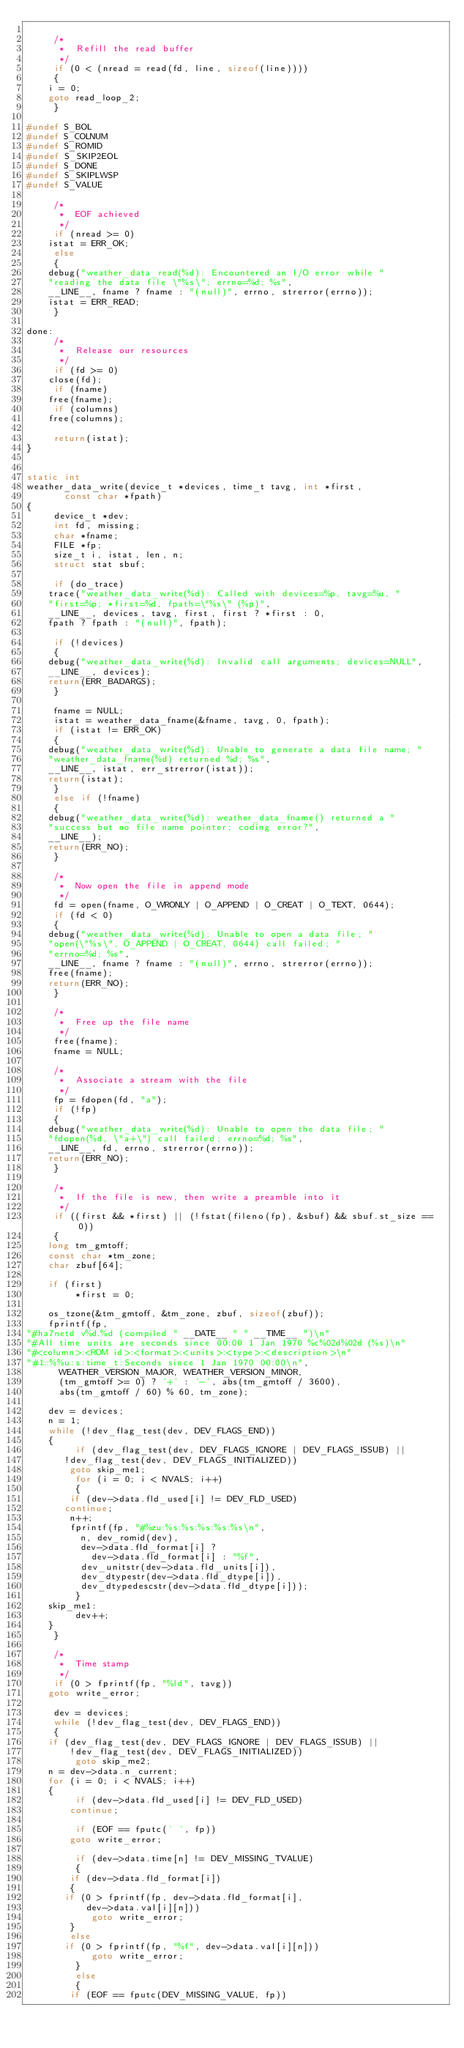<code> <loc_0><loc_0><loc_500><loc_500><_C_>
     /*
      *  Refill the read buffer
      */
     if (0 < (nread = read(fd, line, sizeof(line))))
     {
	  i = 0;
	  goto read_loop_2;
     }

#undef S_BOL
#undef S_COLNUM
#undef S_ROMID
#undef S_SKIP2EOL
#undef S_DONE
#undef S_SKIPLWSP
#undef S_VALUE

     /*
      *  EOF achieved
      */
     if (nread >= 0)
	  istat = ERR_OK;
     else
     {
	  debug("weather_data_read(%d): Encountered an I/O error while "
		"reading the data file \"%s\"; errno=%d; %s",
		__LINE__, fname ? fname : "(null)", errno, strerror(errno));
	  istat = ERR_READ;
     }

done:
     /*
      *  Release our resources
      */
     if (fd >= 0)
	  close(fd);
     if (fname)
	  free(fname);
     if (columns)
	  free(columns);

     return(istat);
}


static int
weather_data_write(device_t *devices, time_t tavg, int *first,
		   const char *fpath)
{
     device_t *dev;
     int fd, missing;
     char *fname;
     FILE *fp;
     size_t i, istat, len, n;
     struct stat sbuf;

     if (do_trace)
	  trace("weather_data_write(%d): Called with devices=%p, tavg=%u, "
		"first=%p; *first=%d, fpath=\"%s\" (%p)",
		__LINE__, devices, tavg, first, first ? *first : 0,
		fpath ? fpath : "(null)", fpath);

     if (!devices)
     {
	  debug("weather_data_write(%d): Invalid call arguments; devices=NULL",
		__LINE__, devices);
	  return(ERR_BADARGS);
     }

     fname = NULL;
     istat = weather_data_fname(&fname, tavg, 0, fpath);
     if (istat != ERR_OK)
     {
	  debug("weather_data_write(%d): Unable to generate a data file name; "
		"weather_data_fname(%d) returned %d; %s",
		__LINE__, istat, err_strerror(istat));
	  return(istat);
     }
     else if (!fname)
     {
	  debug("weather_data_write(%d): weather_data_fname() returned a "
		"success but no file name pointer; coding error?",
		__LINE__);
	  return(ERR_NO);
     }

     /*
      *  Now open the file in append mode
      */
     fd = open(fname, O_WRONLY | O_APPEND | O_CREAT | O_TEXT, 0644);
     if (fd < 0)
     {
	  debug("weather_data_write(%d): Unable to open a data file; "
		"open(\"%s\", O_APPEND | O_CREAT, 0644) call failed; "
		"errno=%d; %s",
		__LINE__, fname ? fname : "(null)", errno, strerror(errno));
	  free(fname);
	  return(ERR_NO);
     }

     /*
      *  Free up the file name
      */
     free(fname);
     fname = NULL;

     /*
      *  Associate a stream with the file
      */
     fp = fdopen(fd, "a");
     if (!fp)
     {
	  debug("weather_data_write(%d): Unable to open the data file; "
		"fdopen(%d, \"a+\") call failed; errno=%d; %s",
		__LINE__, fd, errno, strerror(errno));
	  return(ERR_NO);
     }

     /*
      *  If the file is new, then write a preamble into it
      */
     if ((first && *first) || (!fstat(fileno(fp), &sbuf) && sbuf.st_size == 0))
     {
	  long tm_gmtoff;
	  const char *tm_zone;
	  char zbuf[64];

	  if (first)
	       *first = 0;

	  os_tzone(&tm_gmtoff, &tm_zone, zbuf, sizeof(zbuf));
	  fprintf(fp,
"#ha7netd v%d.%d (compiled " __DATE__ " " __TIME__ ")\n"
"#All time units are seconds since 00:00 1 Jan 1970 %c%02d%02d (%s)\n"
"#<column>:<ROM id>:<format>:<units>:<type>:<description>\n"
"#1::%%u:s:time_t:Seconds since 1 Jan 1970 00:00\n",
		  WEATHER_VERSION_MAJOR, WEATHER_VERSION_MINOR,
		  (tm_gmtoff >= 0) ? '+' : '-', abs(tm_gmtoff / 3600),
		  abs(tm_gmtoff / 60) % 60, tm_zone);

	  dev = devices;
	  n = 1;
	  while (!dev_flag_test(dev, DEV_FLAGS_END))
	  {
	       if (dev_flag_test(dev, DEV_FLAGS_IGNORE | DEV_FLAGS_ISSUB) ||
		   !dev_flag_test(dev, DEV_FLAGS_INITIALIZED))
		    goto skip_me1;
	       for (i = 0; i < NVALS; i++)
	       {
		    if (dev->data.fld_used[i] != DEV_FLD_USED)
			 continue;
		    n++;
		    fprintf(fp, "#%zu:%s:%s:%s:%s:%s\n",
			    n, dev_romid(dev),
			    dev->data.fld_format[i] ?
			      dev->data.fld_format[i] : "%f",
			    dev_unitstr(dev->data.fld_units[i]),
			    dev_dtypestr(dev->data.fld_dtype[i]),
			    dev_dtypedescstr(dev->data.fld_dtype[i]));
	       }
	  skip_me1:
	       dev++;
	  }
     }

     /*
      *  Time stamp
      */
     if (0 > fprintf(fp, "%ld", tavg))
	  goto write_error;

     dev = devices;
     while (!dev_flag_test(dev, DEV_FLAGS_END))
     {
	  if (dev_flag_test(dev, DEV_FLAGS_IGNORE | DEV_FLAGS_ISSUB) ||
	      !dev_flag_test(dev, DEV_FLAGS_INITIALIZED))
	       goto skip_me2;
	  n = dev->data.n_current;
	  for (i = 0; i < NVALS; i++)
	  {
	       if (dev->data.fld_used[i] != DEV_FLD_USED)
		    continue;

	       if (EOF == fputc(' ', fp))
		    goto write_error;

	       if (dev->data.time[n] != DEV_MISSING_TVALUE)
	       {
		    if (dev->data.fld_format[i])
		    {
			 if (0 > fprintf(fp, dev->data.fld_format[i],
					 dev->data.val[i][n]))
			      goto write_error;
		    }
		    else
			 if (0 > fprintf(fp, "%f", dev->data.val[i][n]))
			      goto write_error;
	       }
	       else
	       {
		    if (EOF == fputc(DEV_MISSING_VALUE, fp))</code> 